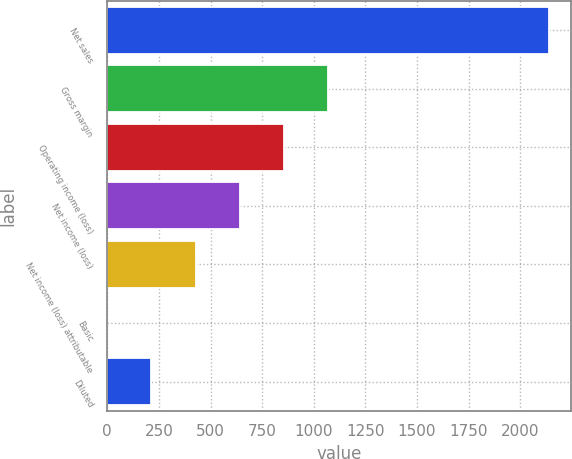Convert chart. <chart><loc_0><loc_0><loc_500><loc_500><bar_chart><fcel>Net sales<fcel>Gross margin<fcel>Operating income (loss)<fcel>Net income (loss)<fcel>Net income (loss) attributable<fcel>Basic<fcel>Diluted<nl><fcel>2139<fcel>1069.52<fcel>855.63<fcel>641.74<fcel>427.85<fcel>0.07<fcel>213.96<nl></chart> 